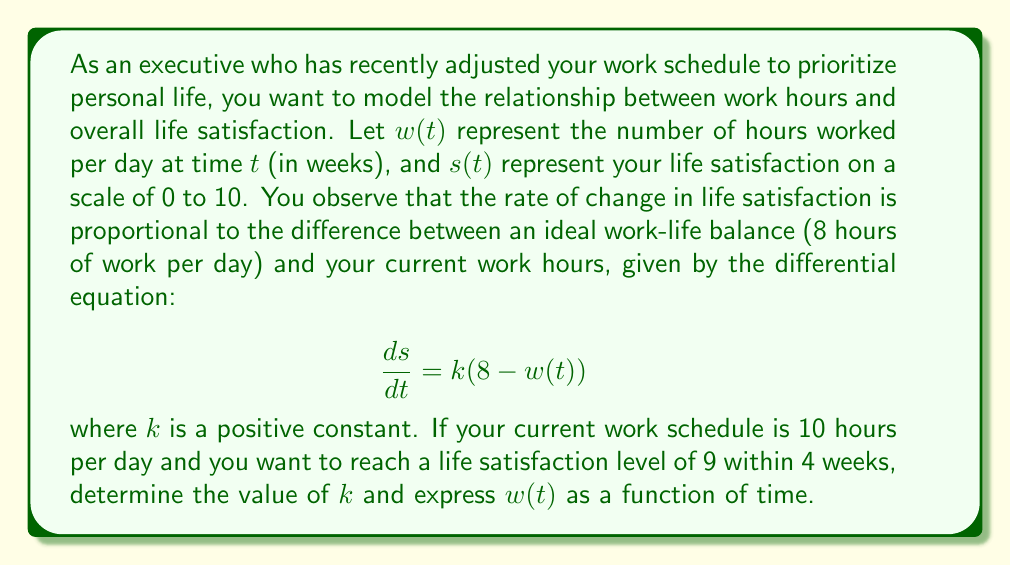Can you answer this question? Let's approach this problem step by step:

1) First, we need to find an expression for $w(t)$. Since we want to reach a balance of 8 hours per day, we can model $w(t)$ as an exponential decay from the initial 10 hours:

   $$w(t) = 8 + 2e^{-at}$$

   where $a$ is a positive constant representing the rate of change in work hours.

2) Now, let's substitute this into our differential equation:

   $$\frac{ds}{dt} = k(8 - (8 + 2e^{-at})) = -2ke^{-at}$$

3) We can solve this differential equation by integrating both sides:

   $$\int \frac{ds}{dt} dt = \int -2ke^{-at} dt$$
   $$s(t) = \frac{2k}{a}e^{-at} + C$$

4) To find $C$, we can use the initial condition. Let's assume the initial satisfaction is 5 (you can adjust this if needed):

   $$5 = \frac{2k}{a} + C$$
   $$C = 5 - \frac{2k}{a}$$

5) So our full solution for $s(t)$ is:

   $$s(t) = \frac{2k}{a}e^{-at} + 5 - \frac{2k}{a}$$

6) Now, we want $s(4) = 9$. Let's substitute this:

   $$9 = \frac{2k}{a}e^{-4a} + 5 - \frac{2k}{a}$$
   $$4 = \frac{2k}{a}(e^{-4a} - 1)$$
   $$2 = \frac{k}{a}(e^{-4a} - 1)$$

7) We also know that after 4 weeks, we want $w(4) = 8$:

   $$8 = 8 + 2e^{-4a}$$
   $$e^{-4a} = 0$$

8) This implies that $a$ is very large, effectively making the change in work hours instantaneous. In a more realistic scenario, we might choose a value like $a = 0.5$, which would reduce work hours to about 8.1 hours after 4 weeks.

9) With $a = 0.5$, we can solve for $k$:

   $$2 = \frac{k}{0.5}(e^{-2} - 1)$$
   $$k = \frac{1}{e^{-2} - 1} \approx 0.3133$$

Therefore, we have:
$$w(t) = 8 + 2e^{-0.5t}$$
$$k \approx 0.3133$$
Answer: $k \approx 0.3133$ and $w(t) = 8 + 2e^{-0.5t}$ 